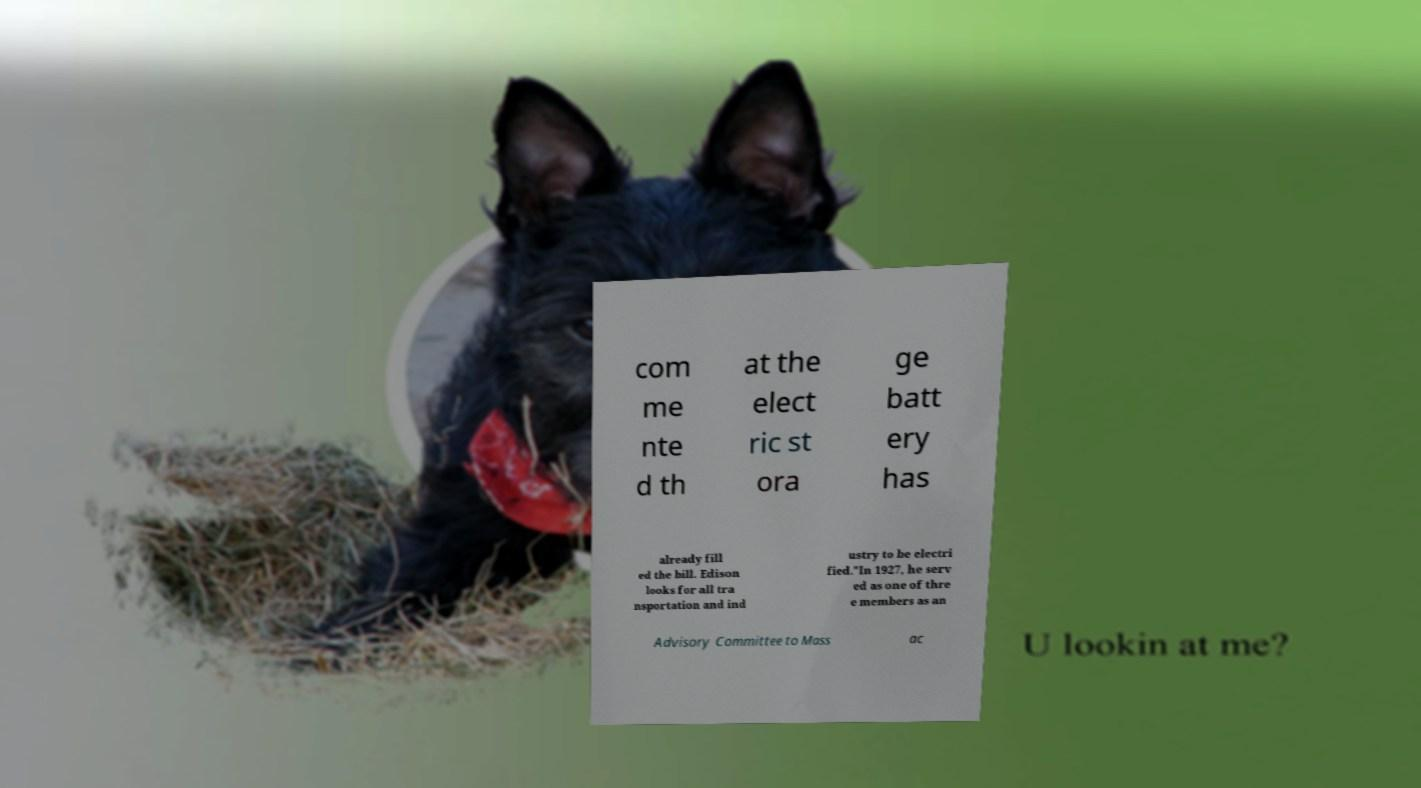Please identify and transcribe the text found in this image. com me nte d th at the elect ric st ora ge batt ery has already fill ed the bill. Edison looks for all tra nsportation and ind ustry to be electri fied."In 1927, he serv ed as one of thre e members as an Advisory Committee to Mass ac 